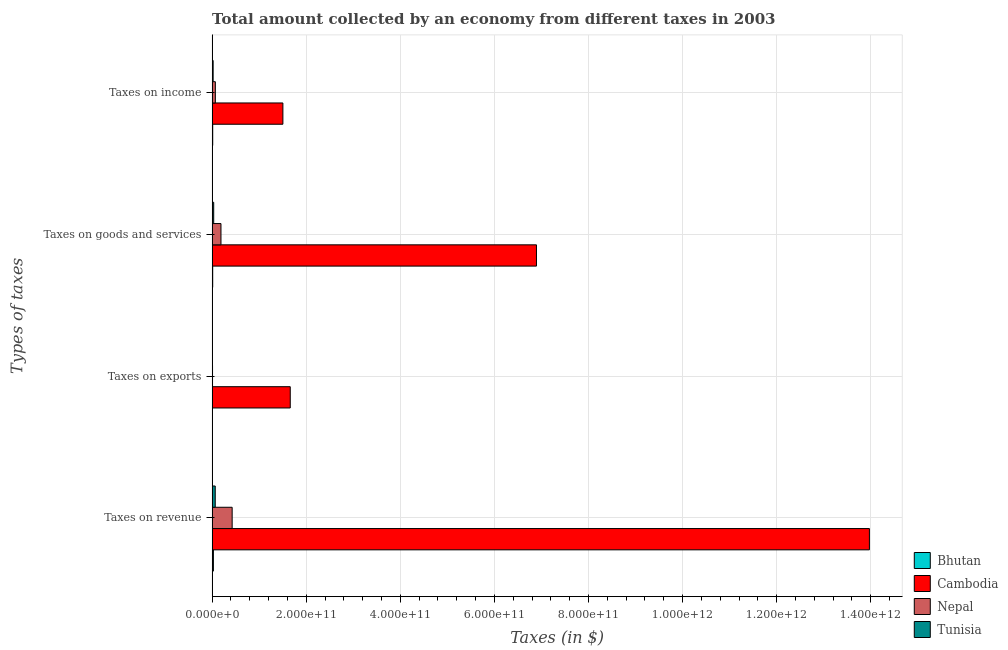How many different coloured bars are there?
Offer a very short reply. 4. How many groups of bars are there?
Offer a very short reply. 4. How many bars are there on the 2nd tick from the bottom?
Your answer should be compact. 4. What is the label of the 2nd group of bars from the top?
Keep it short and to the point. Taxes on goods and services. What is the amount collected as tax on income in Tunisia?
Your response must be concise. 2.18e+09. Across all countries, what is the maximum amount collected as tax on goods?
Offer a terse response. 6.89e+11. Across all countries, what is the minimum amount collected as tax on revenue?
Keep it short and to the point. 2.71e+09. In which country was the amount collected as tax on income maximum?
Give a very brief answer. Cambodia. In which country was the amount collected as tax on income minimum?
Your answer should be very brief. Bhutan. What is the total amount collected as tax on income in the graph?
Your answer should be compact. 1.61e+11. What is the difference between the amount collected as tax on income in Bhutan and that in Cambodia?
Offer a very short reply. -1.49e+11. What is the difference between the amount collected as tax on income in Cambodia and the amount collected as tax on revenue in Bhutan?
Your answer should be very brief. 1.48e+11. What is the average amount collected as tax on revenue per country?
Ensure brevity in your answer.  3.62e+11. What is the difference between the amount collected as tax on goods and amount collected as tax on exports in Cambodia?
Keep it short and to the point. 5.23e+11. What is the ratio of the amount collected as tax on goods in Bhutan to that in Nepal?
Offer a terse response. 0.06. Is the amount collected as tax on exports in Cambodia less than that in Tunisia?
Your response must be concise. No. Is the difference between the amount collected as tax on income in Bhutan and Nepal greater than the difference between the amount collected as tax on goods in Bhutan and Nepal?
Your answer should be compact. Yes. What is the difference between the highest and the second highest amount collected as tax on goods?
Your response must be concise. 6.71e+11. What is the difference between the highest and the lowest amount collected as tax on exports?
Offer a terse response. 1.66e+11. In how many countries, is the amount collected as tax on goods greater than the average amount collected as tax on goods taken over all countries?
Offer a very short reply. 1. What does the 2nd bar from the top in Taxes on exports represents?
Provide a short and direct response. Nepal. What does the 2nd bar from the bottom in Taxes on exports represents?
Your answer should be very brief. Cambodia. How many bars are there?
Keep it short and to the point. 16. Are all the bars in the graph horizontal?
Keep it short and to the point. Yes. How many countries are there in the graph?
Make the answer very short. 4. What is the difference between two consecutive major ticks on the X-axis?
Give a very brief answer. 2.00e+11. Does the graph contain any zero values?
Provide a succinct answer. No. Where does the legend appear in the graph?
Ensure brevity in your answer.  Bottom right. How are the legend labels stacked?
Your response must be concise. Vertical. What is the title of the graph?
Your response must be concise. Total amount collected by an economy from different taxes in 2003. What is the label or title of the X-axis?
Offer a very short reply. Taxes (in $). What is the label or title of the Y-axis?
Provide a succinct answer. Types of taxes. What is the Taxes (in $) in Bhutan in Taxes on revenue?
Your response must be concise. 2.71e+09. What is the Taxes (in $) of Cambodia in Taxes on revenue?
Your answer should be very brief. 1.40e+12. What is the Taxes (in $) in Nepal in Taxes on revenue?
Make the answer very short. 4.26e+1. What is the Taxes (in $) in Tunisia in Taxes on revenue?
Your response must be concise. 6.63e+09. What is the Taxes (in $) in Bhutan in Taxes on exports?
Your answer should be very brief. 7.63e+05. What is the Taxes (in $) in Cambodia in Taxes on exports?
Give a very brief answer. 1.66e+11. What is the Taxes (in $) in Nepal in Taxes on exports?
Your answer should be very brief. 8.56e+08. What is the Taxes (in $) in Tunisia in Taxes on exports?
Offer a terse response. 8.70e+06. What is the Taxes (in $) of Bhutan in Taxes on goods and services?
Your answer should be compact. 1.22e+09. What is the Taxes (in $) of Cambodia in Taxes on goods and services?
Give a very brief answer. 6.89e+11. What is the Taxes (in $) in Nepal in Taxes on goods and services?
Provide a succinct answer. 1.88e+1. What is the Taxes (in $) of Tunisia in Taxes on goods and services?
Offer a very short reply. 3.36e+09. What is the Taxes (in $) of Bhutan in Taxes on income?
Offer a terse response. 1.27e+09. What is the Taxes (in $) of Cambodia in Taxes on income?
Offer a terse response. 1.50e+11. What is the Taxes (in $) of Nepal in Taxes on income?
Make the answer very short. 6.88e+09. What is the Taxes (in $) in Tunisia in Taxes on income?
Provide a short and direct response. 2.18e+09. Across all Types of taxes, what is the maximum Taxes (in $) of Bhutan?
Make the answer very short. 2.71e+09. Across all Types of taxes, what is the maximum Taxes (in $) in Cambodia?
Your response must be concise. 1.40e+12. Across all Types of taxes, what is the maximum Taxes (in $) in Nepal?
Make the answer very short. 4.26e+1. Across all Types of taxes, what is the maximum Taxes (in $) in Tunisia?
Your answer should be very brief. 6.63e+09. Across all Types of taxes, what is the minimum Taxes (in $) of Bhutan?
Give a very brief answer. 7.63e+05. Across all Types of taxes, what is the minimum Taxes (in $) in Cambodia?
Offer a terse response. 1.50e+11. Across all Types of taxes, what is the minimum Taxes (in $) of Nepal?
Give a very brief answer. 8.56e+08. Across all Types of taxes, what is the minimum Taxes (in $) in Tunisia?
Your answer should be very brief. 8.70e+06. What is the total Taxes (in $) in Bhutan in the graph?
Keep it short and to the point. 5.21e+09. What is the total Taxes (in $) in Cambodia in the graph?
Give a very brief answer. 2.40e+12. What is the total Taxes (in $) of Nepal in the graph?
Give a very brief answer. 6.91e+1. What is the total Taxes (in $) of Tunisia in the graph?
Your answer should be compact. 1.22e+1. What is the difference between the Taxes (in $) in Bhutan in Taxes on revenue and that in Taxes on exports?
Your response must be concise. 2.71e+09. What is the difference between the Taxes (in $) in Cambodia in Taxes on revenue and that in Taxes on exports?
Your response must be concise. 1.23e+12. What is the difference between the Taxes (in $) of Nepal in Taxes on revenue and that in Taxes on exports?
Provide a succinct answer. 4.17e+1. What is the difference between the Taxes (in $) in Tunisia in Taxes on revenue and that in Taxes on exports?
Make the answer very short. 6.62e+09. What is the difference between the Taxes (in $) in Bhutan in Taxes on revenue and that in Taxes on goods and services?
Offer a very short reply. 1.49e+09. What is the difference between the Taxes (in $) in Cambodia in Taxes on revenue and that in Taxes on goods and services?
Provide a succinct answer. 7.08e+11. What is the difference between the Taxes (in $) in Nepal in Taxes on revenue and that in Taxes on goods and services?
Your answer should be very brief. 2.38e+1. What is the difference between the Taxes (in $) of Tunisia in Taxes on revenue and that in Taxes on goods and services?
Offer a terse response. 3.27e+09. What is the difference between the Taxes (in $) of Bhutan in Taxes on revenue and that in Taxes on income?
Provide a succinct answer. 1.44e+09. What is the difference between the Taxes (in $) in Cambodia in Taxes on revenue and that in Taxes on income?
Your response must be concise. 1.25e+12. What is the difference between the Taxes (in $) in Nepal in Taxes on revenue and that in Taxes on income?
Keep it short and to the point. 3.57e+1. What is the difference between the Taxes (in $) of Tunisia in Taxes on revenue and that in Taxes on income?
Keep it short and to the point. 4.45e+09. What is the difference between the Taxes (in $) of Bhutan in Taxes on exports and that in Taxes on goods and services?
Provide a short and direct response. -1.22e+09. What is the difference between the Taxes (in $) in Cambodia in Taxes on exports and that in Taxes on goods and services?
Make the answer very short. -5.23e+11. What is the difference between the Taxes (in $) of Nepal in Taxes on exports and that in Taxes on goods and services?
Ensure brevity in your answer.  -1.79e+1. What is the difference between the Taxes (in $) in Tunisia in Taxes on exports and that in Taxes on goods and services?
Provide a short and direct response. -3.35e+09. What is the difference between the Taxes (in $) in Bhutan in Taxes on exports and that in Taxes on income?
Offer a very short reply. -1.27e+09. What is the difference between the Taxes (in $) in Cambodia in Taxes on exports and that in Taxes on income?
Ensure brevity in your answer.  1.56e+1. What is the difference between the Taxes (in $) of Nepal in Taxes on exports and that in Taxes on income?
Offer a very short reply. -6.02e+09. What is the difference between the Taxes (in $) of Tunisia in Taxes on exports and that in Taxes on income?
Ensure brevity in your answer.  -2.17e+09. What is the difference between the Taxes (in $) of Bhutan in Taxes on goods and services and that in Taxes on income?
Provide a succinct answer. -5.32e+07. What is the difference between the Taxes (in $) in Cambodia in Taxes on goods and services and that in Taxes on income?
Provide a short and direct response. 5.39e+11. What is the difference between the Taxes (in $) in Nepal in Taxes on goods and services and that in Taxes on income?
Keep it short and to the point. 1.19e+1. What is the difference between the Taxes (in $) in Tunisia in Taxes on goods and services and that in Taxes on income?
Provide a short and direct response. 1.18e+09. What is the difference between the Taxes (in $) of Bhutan in Taxes on revenue and the Taxes (in $) of Cambodia in Taxes on exports?
Offer a terse response. -1.63e+11. What is the difference between the Taxes (in $) of Bhutan in Taxes on revenue and the Taxes (in $) of Nepal in Taxes on exports?
Your answer should be very brief. 1.86e+09. What is the difference between the Taxes (in $) in Bhutan in Taxes on revenue and the Taxes (in $) in Tunisia in Taxes on exports?
Give a very brief answer. 2.70e+09. What is the difference between the Taxes (in $) in Cambodia in Taxes on revenue and the Taxes (in $) in Nepal in Taxes on exports?
Your response must be concise. 1.40e+12. What is the difference between the Taxes (in $) in Cambodia in Taxes on revenue and the Taxes (in $) in Tunisia in Taxes on exports?
Give a very brief answer. 1.40e+12. What is the difference between the Taxes (in $) of Nepal in Taxes on revenue and the Taxes (in $) of Tunisia in Taxes on exports?
Offer a terse response. 4.26e+1. What is the difference between the Taxes (in $) of Bhutan in Taxes on revenue and the Taxes (in $) of Cambodia in Taxes on goods and services?
Offer a very short reply. -6.87e+11. What is the difference between the Taxes (in $) in Bhutan in Taxes on revenue and the Taxes (in $) in Nepal in Taxes on goods and services?
Offer a very short reply. -1.61e+1. What is the difference between the Taxes (in $) of Bhutan in Taxes on revenue and the Taxes (in $) of Tunisia in Taxes on goods and services?
Your answer should be compact. -6.46e+08. What is the difference between the Taxes (in $) in Cambodia in Taxes on revenue and the Taxes (in $) in Nepal in Taxes on goods and services?
Give a very brief answer. 1.38e+12. What is the difference between the Taxes (in $) of Cambodia in Taxes on revenue and the Taxes (in $) of Tunisia in Taxes on goods and services?
Provide a succinct answer. 1.39e+12. What is the difference between the Taxes (in $) of Nepal in Taxes on revenue and the Taxes (in $) of Tunisia in Taxes on goods and services?
Give a very brief answer. 3.92e+1. What is the difference between the Taxes (in $) in Bhutan in Taxes on revenue and the Taxes (in $) in Cambodia in Taxes on income?
Make the answer very short. -1.48e+11. What is the difference between the Taxes (in $) of Bhutan in Taxes on revenue and the Taxes (in $) of Nepal in Taxes on income?
Your answer should be very brief. -4.17e+09. What is the difference between the Taxes (in $) of Bhutan in Taxes on revenue and the Taxes (in $) of Tunisia in Taxes on income?
Provide a succinct answer. 5.37e+08. What is the difference between the Taxes (in $) in Cambodia in Taxes on revenue and the Taxes (in $) in Nepal in Taxes on income?
Your answer should be very brief. 1.39e+12. What is the difference between the Taxes (in $) in Cambodia in Taxes on revenue and the Taxes (in $) in Tunisia in Taxes on income?
Ensure brevity in your answer.  1.39e+12. What is the difference between the Taxes (in $) of Nepal in Taxes on revenue and the Taxes (in $) of Tunisia in Taxes on income?
Your answer should be very brief. 4.04e+1. What is the difference between the Taxes (in $) of Bhutan in Taxes on exports and the Taxes (in $) of Cambodia in Taxes on goods and services?
Provide a succinct answer. -6.89e+11. What is the difference between the Taxes (in $) in Bhutan in Taxes on exports and the Taxes (in $) in Nepal in Taxes on goods and services?
Keep it short and to the point. -1.88e+1. What is the difference between the Taxes (in $) of Bhutan in Taxes on exports and the Taxes (in $) of Tunisia in Taxes on goods and services?
Offer a very short reply. -3.36e+09. What is the difference between the Taxes (in $) of Cambodia in Taxes on exports and the Taxes (in $) of Nepal in Taxes on goods and services?
Make the answer very short. 1.47e+11. What is the difference between the Taxes (in $) in Cambodia in Taxes on exports and the Taxes (in $) in Tunisia in Taxes on goods and services?
Offer a very short reply. 1.63e+11. What is the difference between the Taxes (in $) of Nepal in Taxes on exports and the Taxes (in $) of Tunisia in Taxes on goods and services?
Your response must be concise. -2.50e+09. What is the difference between the Taxes (in $) of Bhutan in Taxes on exports and the Taxes (in $) of Cambodia in Taxes on income?
Offer a terse response. -1.50e+11. What is the difference between the Taxes (in $) of Bhutan in Taxes on exports and the Taxes (in $) of Nepal in Taxes on income?
Keep it short and to the point. -6.88e+09. What is the difference between the Taxes (in $) of Bhutan in Taxes on exports and the Taxes (in $) of Tunisia in Taxes on income?
Your answer should be compact. -2.18e+09. What is the difference between the Taxes (in $) of Cambodia in Taxes on exports and the Taxes (in $) of Nepal in Taxes on income?
Your answer should be compact. 1.59e+11. What is the difference between the Taxes (in $) of Cambodia in Taxes on exports and the Taxes (in $) of Tunisia in Taxes on income?
Provide a short and direct response. 1.64e+11. What is the difference between the Taxes (in $) in Nepal in Taxes on exports and the Taxes (in $) in Tunisia in Taxes on income?
Give a very brief answer. -1.32e+09. What is the difference between the Taxes (in $) of Bhutan in Taxes on goods and services and the Taxes (in $) of Cambodia in Taxes on income?
Your answer should be compact. -1.49e+11. What is the difference between the Taxes (in $) in Bhutan in Taxes on goods and services and the Taxes (in $) in Nepal in Taxes on income?
Your answer should be very brief. -5.66e+09. What is the difference between the Taxes (in $) of Bhutan in Taxes on goods and services and the Taxes (in $) of Tunisia in Taxes on income?
Provide a succinct answer. -9.57e+08. What is the difference between the Taxes (in $) of Cambodia in Taxes on goods and services and the Taxes (in $) of Nepal in Taxes on income?
Ensure brevity in your answer.  6.83e+11. What is the difference between the Taxes (in $) in Cambodia in Taxes on goods and services and the Taxes (in $) in Tunisia in Taxes on income?
Your response must be concise. 6.87e+11. What is the difference between the Taxes (in $) of Nepal in Taxes on goods and services and the Taxes (in $) of Tunisia in Taxes on income?
Your response must be concise. 1.66e+1. What is the average Taxes (in $) in Bhutan per Types of taxes?
Provide a succinct answer. 1.30e+09. What is the average Taxes (in $) in Cambodia per Types of taxes?
Your response must be concise. 6.01e+11. What is the average Taxes (in $) in Nepal per Types of taxes?
Provide a short and direct response. 1.73e+1. What is the average Taxes (in $) in Tunisia per Types of taxes?
Offer a very short reply. 3.04e+09. What is the difference between the Taxes (in $) in Bhutan and Taxes (in $) in Cambodia in Taxes on revenue?
Ensure brevity in your answer.  -1.39e+12. What is the difference between the Taxes (in $) of Bhutan and Taxes (in $) of Nepal in Taxes on revenue?
Your answer should be very brief. -3.99e+1. What is the difference between the Taxes (in $) of Bhutan and Taxes (in $) of Tunisia in Taxes on revenue?
Your answer should be compact. -3.92e+09. What is the difference between the Taxes (in $) of Cambodia and Taxes (in $) of Nepal in Taxes on revenue?
Provide a short and direct response. 1.35e+12. What is the difference between the Taxes (in $) of Cambodia and Taxes (in $) of Tunisia in Taxes on revenue?
Give a very brief answer. 1.39e+12. What is the difference between the Taxes (in $) of Nepal and Taxes (in $) of Tunisia in Taxes on revenue?
Provide a short and direct response. 3.60e+1. What is the difference between the Taxes (in $) in Bhutan and Taxes (in $) in Cambodia in Taxes on exports?
Provide a short and direct response. -1.66e+11. What is the difference between the Taxes (in $) in Bhutan and Taxes (in $) in Nepal in Taxes on exports?
Make the answer very short. -8.55e+08. What is the difference between the Taxes (in $) of Bhutan and Taxes (in $) of Tunisia in Taxes on exports?
Your answer should be very brief. -7.94e+06. What is the difference between the Taxes (in $) of Cambodia and Taxes (in $) of Nepal in Taxes on exports?
Provide a short and direct response. 1.65e+11. What is the difference between the Taxes (in $) of Cambodia and Taxes (in $) of Tunisia in Taxes on exports?
Ensure brevity in your answer.  1.66e+11. What is the difference between the Taxes (in $) in Nepal and Taxes (in $) in Tunisia in Taxes on exports?
Give a very brief answer. 8.47e+08. What is the difference between the Taxes (in $) in Bhutan and Taxes (in $) in Cambodia in Taxes on goods and services?
Give a very brief answer. -6.88e+11. What is the difference between the Taxes (in $) in Bhutan and Taxes (in $) in Nepal in Taxes on goods and services?
Provide a short and direct response. -1.76e+1. What is the difference between the Taxes (in $) in Bhutan and Taxes (in $) in Tunisia in Taxes on goods and services?
Provide a short and direct response. -2.14e+09. What is the difference between the Taxes (in $) in Cambodia and Taxes (in $) in Nepal in Taxes on goods and services?
Ensure brevity in your answer.  6.71e+11. What is the difference between the Taxes (in $) in Cambodia and Taxes (in $) in Tunisia in Taxes on goods and services?
Ensure brevity in your answer.  6.86e+11. What is the difference between the Taxes (in $) in Nepal and Taxes (in $) in Tunisia in Taxes on goods and services?
Ensure brevity in your answer.  1.54e+1. What is the difference between the Taxes (in $) in Bhutan and Taxes (in $) in Cambodia in Taxes on income?
Ensure brevity in your answer.  -1.49e+11. What is the difference between the Taxes (in $) of Bhutan and Taxes (in $) of Nepal in Taxes on income?
Offer a terse response. -5.61e+09. What is the difference between the Taxes (in $) of Bhutan and Taxes (in $) of Tunisia in Taxes on income?
Your answer should be compact. -9.04e+08. What is the difference between the Taxes (in $) in Cambodia and Taxes (in $) in Nepal in Taxes on income?
Ensure brevity in your answer.  1.44e+11. What is the difference between the Taxes (in $) in Cambodia and Taxes (in $) in Tunisia in Taxes on income?
Give a very brief answer. 1.48e+11. What is the difference between the Taxes (in $) of Nepal and Taxes (in $) of Tunisia in Taxes on income?
Give a very brief answer. 4.70e+09. What is the ratio of the Taxes (in $) of Bhutan in Taxes on revenue to that in Taxes on exports?
Your answer should be compact. 3556.44. What is the ratio of the Taxes (in $) in Cambodia in Taxes on revenue to that in Taxes on exports?
Your answer should be compact. 8.41. What is the ratio of the Taxes (in $) of Nepal in Taxes on revenue to that in Taxes on exports?
Your response must be concise. 49.77. What is the ratio of the Taxes (in $) in Tunisia in Taxes on revenue to that in Taxes on exports?
Provide a short and direct response. 762.16. What is the ratio of the Taxes (in $) of Bhutan in Taxes on revenue to that in Taxes on goods and services?
Provide a short and direct response. 2.23. What is the ratio of the Taxes (in $) of Cambodia in Taxes on revenue to that in Taxes on goods and services?
Provide a succinct answer. 2.03. What is the ratio of the Taxes (in $) in Nepal in Taxes on revenue to that in Taxes on goods and services?
Offer a very short reply. 2.26. What is the ratio of the Taxes (in $) of Tunisia in Taxes on revenue to that in Taxes on goods and services?
Your response must be concise. 1.97. What is the ratio of the Taxes (in $) of Bhutan in Taxes on revenue to that in Taxes on income?
Your answer should be very brief. 2.13. What is the ratio of the Taxes (in $) of Cambodia in Taxes on revenue to that in Taxes on income?
Ensure brevity in your answer.  9.29. What is the ratio of the Taxes (in $) in Nepal in Taxes on revenue to that in Taxes on income?
Keep it short and to the point. 6.19. What is the ratio of the Taxes (in $) in Tunisia in Taxes on revenue to that in Taxes on income?
Make the answer very short. 3.05. What is the ratio of the Taxes (in $) in Bhutan in Taxes on exports to that in Taxes on goods and services?
Your answer should be very brief. 0. What is the ratio of the Taxes (in $) in Cambodia in Taxes on exports to that in Taxes on goods and services?
Provide a succinct answer. 0.24. What is the ratio of the Taxes (in $) in Nepal in Taxes on exports to that in Taxes on goods and services?
Offer a very short reply. 0.05. What is the ratio of the Taxes (in $) in Tunisia in Taxes on exports to that in Taxes on goods and services?
Your response must be concise. 0. What is the ratio of the Taxes (in $) of Bhutan in Taxes on exports to that in Taxes on income?
Offer a very short reply. 0. What is the ratio of the Taxes (in $) of Cambodia in Taxes on exports to that in Taxes on income?
Give a very brief answer. 1.1. What is the ratio of the Taxes (in $) of Nepal in Taxes on exports to that in Taxes on income?
Provide a succinct answer. 0.12. What is the ratio of the Taxes (in $) of Tunisia in Taxes on exports to that in Taxes on income?
Ensure brevity in your answer.  0. What is the ratio of the Taxes (in $) in Bhutan in Taxes on goods and services to that in Taxes on income?
Make the answer very short. 0.96. What is the ratio of the Taxes (in $) of Cambodia in Taxes on goods and services to that in Taxes on income?
Your answer should be compact. 4.58. What is the ratio of the Taxes (in $) of Nepal in Taxes on goods and services to that in Taxes on income?
Provide a short and direct response. 2.73. What is the ratio of the Taxes (in $) in Tunisia in Taxes on goods and services to that in Taxes on income?
Make the answer very short. 1.54. What is the difference between the highest and the second highest Taxes (in $) in Bhutan?
Keep it short and to the point. 1.44e+09. What is the difference between the highest and the second highest Taxes (in $) in Cambodia?
Your answer should be compact. 7.08e+11. What is the difference between the highest and the second highest Taxes (in $) in Nepal?
Provide a succinct answer. 2.38e+1. What is the difference between the highest and the second highest Taxes (in $) in Tunisia?
Your answer should be very brief. 3.27e+09. What is the difference between the highest and the lowest Taxes (in $) in Bhutan?
Offer a terse response. 2.71e+09. What is the difference between the highest and the lowest Taxes (in $) of Cambodia?
Offer a terse response. 1.25e+12. What is the difference between the highest and the lowest Taxes (in $) of Nepal?
Your answer should be compact. 4.17e+1. What is the difference between the highest and the lowest Taxes (in $) in Tunisia?
Ensure brevity in your answer.  6.62e+09. 